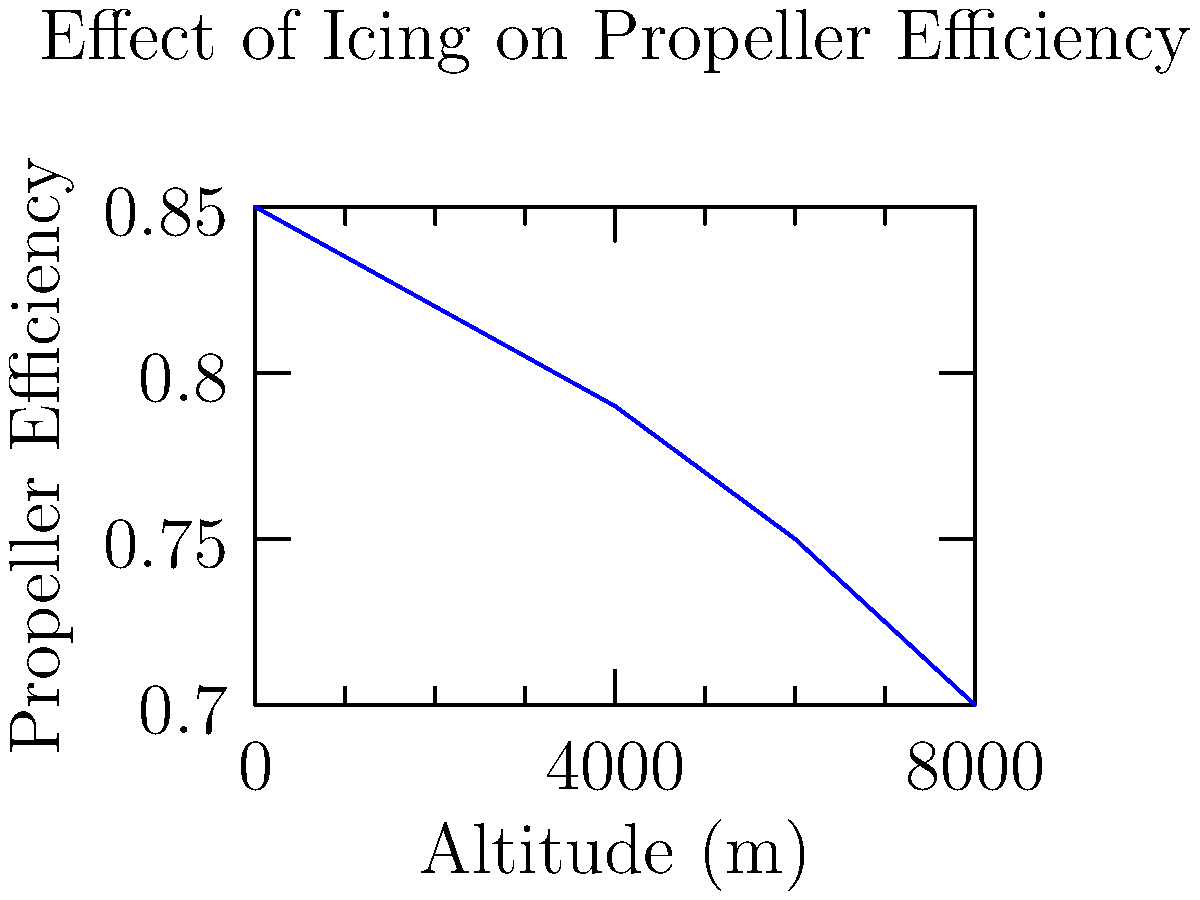Given the graph showing the relationship between altitude and propeller efficiency under icing conditions, calculate the rate of change in propeller efficiency with respect to altitude between 2000m and 6000m. Express your answer in terms of change in efficiency per 1000m increase in altitude. To solve this problem, we'll follow these steps:

1. Identify the propeller efficiency values at 2000m and 6000m:
   At 2000m: $\eta_1 = 0.82$
   At 6000m: $\eta_2 = 0.75$

2. Calculate the total change in efficiency:
   $\Delta\eta = \eta_2 - \eta_1 = 0.75 - 0.82 = -0.07$

3. Calculate the change in altitude:
   $\Delta h = 6000m - 2000m = 4000m$

4. Calculate the rate of change in efficiency per meter:
   $\frac{\Delta\eta}{\Delta h} = \frac{-0.07}{4000m} = -1.75 \times 10^{-5}$ per meter

5. Convert to the rate of change per 1000m:
   $\frac{\Delta\eta}{1000m} = (-1.75 \times 10^{-5}) \times 1000 = -0.0175$ per 1000m

This negative value indicates that the propeller efficiency decreases as altitude increases, which is consistent with the effects of icing at higher altitudes.
Answer: $-0.0175$ per 1000m 